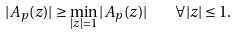Convert formula to latex. <formula><loc_0><loc_0><loc_500><loc_500>| A _ { p } ( z ) | \geq \min _ { | z | = 1 } | A _ { p } ( z ) | \quad \forall | z | \leq 1 .</formula> 